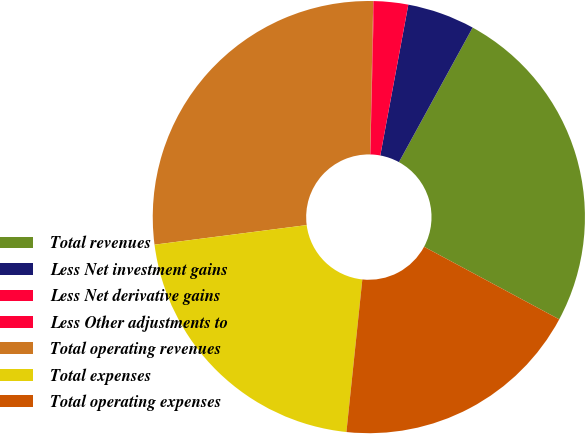Convert chart to OTSL. <chart><loc_0><loc_0><loc_500><loc_500><pie_chart><fcel>Total revenues<fcel>Less Net investment gains<fcel>Less Net derivative gains<fcel>Less Other adjustments to<fcel>Total operating revenues<fcel>Total expenses<fcel>Total operating expenses<nl><fcel>24.87%<fcel>5.05%<fcel>2.55%<fcel>0.05%<fcel>27.36%<fcel>21.31%<fcel>18.81%<nl></chart> 